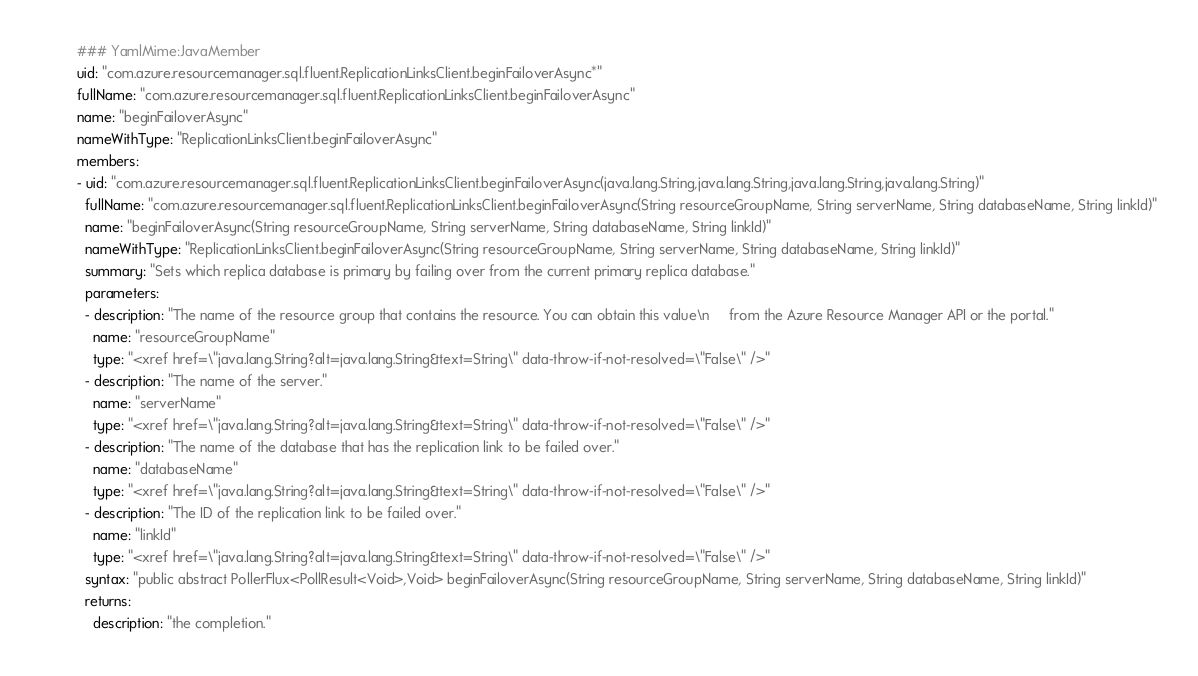Convert code to text. <code><loc_0><loc_0><loc_500><loc_500><_YAML_>### YamlMime:JavaMember
uid: "com.azure.resourcemanager.sql.fluent.ReplicationLinksClient.beginFailoverAsync*"
fullName: "com.azure.resourcemanager.sql.fluent.ReplicationLinksClient.beginFailoverAsync"
name: "beginFailoverAsync"
nameWithType: "ReplicationLinksClient.beginFailoverAsync"
members:
- uid: "com.azure.resourcemanager.sql.fluent.ReplicationLinksClient.beginFailoverAsync(java.lang.String,java.lang.String,java.lang.String,java.lang.String)"
  fullName: "com.azure.resourcemanager.sql.fluent.ReplicationLinksClient.beginFailoverAsync(String resourceGroupName, String serverName, String databaseName, String linkId)"
  name: "beginFailoverAsync(String resourceGroupName, String serverName, String databaseName, String linkId)"
  nameWithType: "ReplicationLinksClient.beginFailoverAsync(String resourceGroupName, String serverName, String databaseName, String linkId)"
  summary: "Sets which replica database is primary by failing over from the current primary replica database."
  parameters:
  - description: "The name of the resource group that contains the resource. You can obtain this value\n     from the Azure Resource Manager API or the portal."
    name: "resourceGroupName"
    type: "<xref href=\"java.lang.String?alt=java.lang.String&text=String\" data-throw-if-not-resolved=\"False\" />"
  - description: "The name of the server."
    name: "serverName"
    type: "<xref href=\"java.lang.String?alt=java.lang.String&text=String\" data-throw-if-not-resolved=\"False\" />"
  - description: "The name of the database that has the replication link to be failed over."
    name: "databaseName"
    type: "<xref href=\"java.lang.String?alt=java.lang.String&text=String\" data-throw-if-not-resolved=\"False\" />"
  - description: "The ID of the replication link to be failed over."
    name: "linkId"
    type: "<xref href=\"java.lang.String?alt=java.lang.String&text=String\" data-throw-if-not-resolved=\"False\" />"
  syntax: "public abstract PollerFlux<PollResult<Void>,Void> beginFailoverAsync(String resourceGroupName, String serverName, String databaseName, String linkId)"
  returns:
    description: "the completion."</code> 